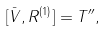Convert formula to latex. <formula><loc_0><loc_0><loc_500><loc_500>[ \bar { V } , R ^ { ( 1 ) } ] = T ^ { \prime \prime } ,</formula> 